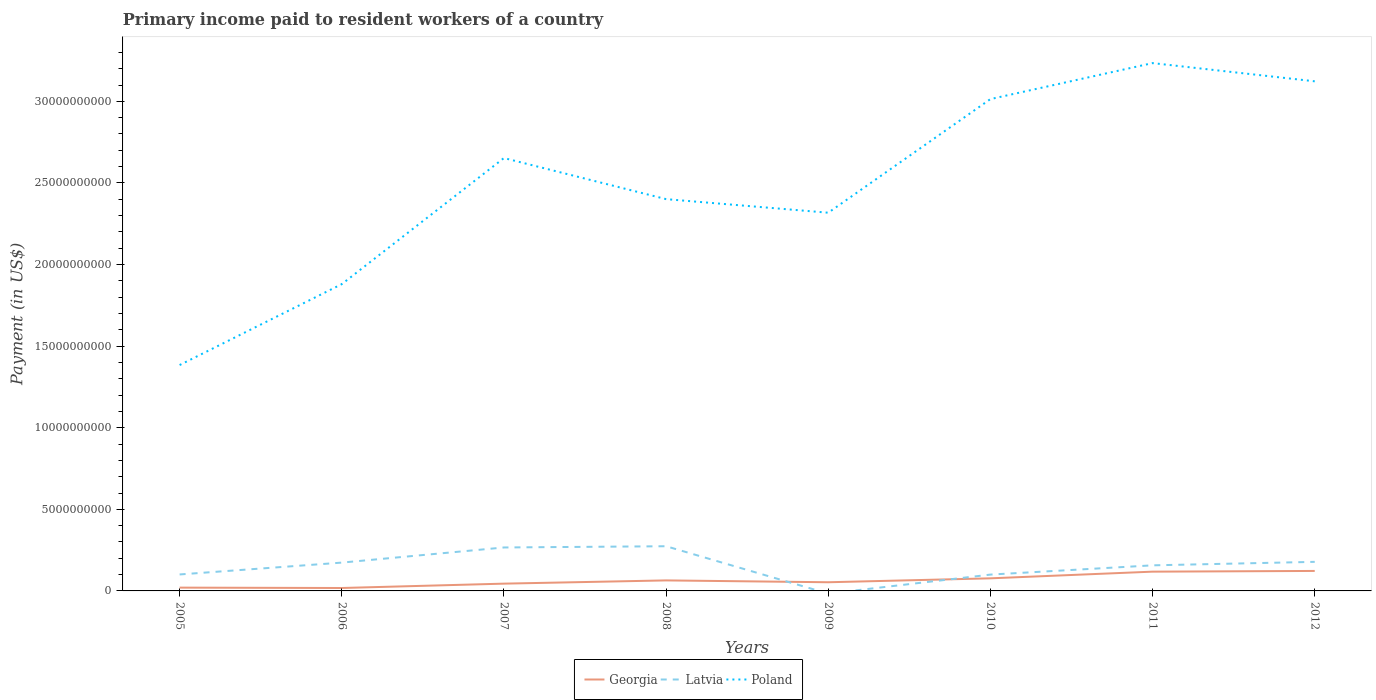Does the line corresponding to Georgia intersect with the line corresponding to Poland?
Your answer should be compact. No. Across all years, what is the maximum amount paid to workers in Georgia?
Give a very brief answer. 1.79e+08. What is the total amount paid to workers in Poland in the graph?
Offer a terse response. -5.82e+09. What is the difference between the highest and the second highest amount paid to workers in Georgia?
Provide a short and direct response. 1.05e+09. What is the difference between the highest and the lowest amount paid to workers in Latvia?
Your response must be concise. 5. Is the amount paid to workers in Georgia strictly greater than the amount paid to workers in Latvia over the years?
Your response must be concise. No. How many years are there in the graph?
Your response must be concise. 8. What is the difference between two consecutive major ticks on the Y-axis?
Give a very brief answer. 5.00e+09. Does the graph contain grids?
Give a very brief answer. No. How many legend labels are there?
Offer a very short reply. 3. How are the legend labels stacked?
Give a very brief answer. Horizontal. What is the title of the graph?
Give a very brief answer. Primary income paid to resident workers of a country. What is the label or title of the Y-axis?
Keep it short and to the point. Payment (in US$). What is the Payment (in US$) in Georgia in 2005?
Provide a short and direct response. 2.02e+08. What is the Payment (in US$) of Latvia in 2005?
Your response must be concise. 1.01e+09. What is the Payment (in US$) in Poland in 2005?
Give a very brief answer. 1.38e+1. What is the Payment (in US$) of Georgia in 2006?
Give a very brief answer. 1.79e+08. What is the Payment (in US$) of Latvia in 2006?
Offer a terse response. 1.74e+09. What is the Payment (in US$) of Poland in 2006?
Make the answer very short. 1.88e+1. What is the Payment (in US$) of Georgia in 2007?
Keep it short and to the point. 4.46e+08. What is the Payment (in US$) of Latvia in 2007?
Make the answer very short. 2.66e+09. What is the Payment (in US$) of Poland in 2007?
Give a very brief answer. 2.65e+1. What is the Payment (in US$) of Georgia in 2008?
Make the answer very short. 6.44e+08. What is the Payment (in US$) in Latvia in 2008?
Ensure brevity in your answer.  2.74e+09. What is the Payment (in US$) in Poland in 2008?
Your answer should be compact. 2.40e+1. What is the Payment (in US$) of Georgia in 2009?
Your answer should be compact. 5.31e+08. What is the Payment (in US$) in Poland in 2009?
Your response must be concise. 2.32e+1. What is the Payment (in US$) of Georgia in 2010?
Provide a succinct answer. 7.71e+08. What is the Payment (in US$) in Latvia in 2010?
Make the answer very short. 1.00e+09. What is the Payment (in US$) of Poland in 2010?
Provide a short and direct response. 3.01e+1. What is the Payment (in US$) in Georgia in 2011?
Provide a succinct answer. 1.18e+09. What is the Payment (in US$) of Latvia in 2011?
Your response must be concise. 1.57e+09. What is the Payment (in US$) of Poland in 2011?
Your response must be concise. 3.23e+1. What is the Payment (in US$) in Georgia in 2012?
Provide a succinct answer. 1.22e+09. What is the Payment (in US$) of Latvia in 2012?
Ensure brevity in your answer.  1.78e+09. What is the Payment (in US$) of Poland in 2012?
Make the answer very short. 3.12e+1. Across all years, what is the maximum Payment (in US$) in Georgia?
Offer a very short reply. 1.22e+09. Across all years, what is the maximum Payment (in US$) in Latvia?
Provide a short and direct response. 2.74e+09. Across all years, what is the maximum Payment (in US$) in Poland?
Your answer should be very brief. 3.23e+1. Across all years, what is the minimum Payment (in US$) of Georgia?
Your answer should be very brief. 1.79e+08. Across all years, what is the minimum Payment (in US$) in Poland?
Your answer should be compact. 1.38e+1. What is the total Payment (in US$) in Georgia in the graph?
Your answer should be compact. 5.18e+09. What is the total Payment (in US$) in Latvia in the graph?
Make the answer very short. 1.25e+1. What is the total Payment (in US$) in Poland in the graph?
Make the answer very short. 2.00e+11. What is the difference between the Payment (in US$) in Georgia in 2005 and that in 2006?
Your answer should be very brief. 2.26e+07. What is the difference between the Payment (in US$) in Latvia in 2005 and that in 2006?
Your answer should be compact. -7.26e+08. What is the difference between the Payment (in US$) of Poland in 2005 and that in 2006?
Your answer should be compact. -4.96e+09. What is the difference between the Payment (in US$) of Georgia in 2005 and that in 2007?
Offer a terse response. -2.44e+08. What is the difference between the Payment (in US$) in Latvia in 2005 and that in 2007?
Give a very brief answer. -1.65e+09. What is the difference between the Payment (in US$) of Poland in 2005 and that in 2007?
Offer a very short reply. -1.27e+1. What is the difference between the Payment (in US$) in Georgia in 2005 and that in 2008?
Offer a terse response. -4.42e+08. What is the difference between the Payment (in US$) of Latvia in 2005 and that in 2008?
Your response must be concise. -1.73e+09. What is the difference between the Payment (in US$) in Poland in 2005 and that in 2008?
Keep it short and to the point. -1.02e+1. What is the difference between the Payment (in US$) in Georgia in 2005 and that in 2009?
Offer a terse response. -3.29e+08. What is the difference between the Payment (in US$) of Poland in 2005 and that in 2009?
Offer a terse response. -9.34e+09. What is the difference between the Payment (in US$) of Georgia in 2005 and that in 2010?
Ensure brevity in your answer.  -5.70e+08. What is the difference between the Payment (in US$) of Latvia in 2005 and that in 2010?
Keep it short and to the point. 8.55e+06. What is the difference between the Payment (in US$) in Poland in 2005 and that in 2010?
Make the answer very short. -1.63e+1. What is the difference between the Payment (in US$) in Georgia in 2005 and that in 2011?
Give a very brief answer. -9.79e+08. What is the difference between the Payment (in US$) in Latvia in 2005 and that in 2011?
Ensure brevity in your answer.  -5.59e+08. What is the difference between the Payment (in US$) in Poland in 2005 and that in 2011?
Make the answer very short. -1.85e+1. What is the difference between the Payment (in US$) in Georgia in 2005 and that in 2012?
Keep it short and to the point. -1.02e+09. What is the difference between the Payment (in US$) of Latvia in 2005 and that in 2012?
Provide a succinct answer. -7.72e+08. What is the difference between the Payment (in US$) in Poland in 2005 and that in 2012?
Offer a very short reply. -1.74e+1. What is the difference between the Payment (in US$) of Georgia in 2006 and that in 2007?
Provide a short and direct response. -2.67e+08. What is the difference between the Payment (in US$) of Latvia in 2006 and that in 2007?
Provide a short and direct response. -9.28e+08. What is the difference between the Payment (in US$) of Poland in 2006 and that in 2007?
Keep it short and to the point. -7.73e+09. What is the difference between the Payment (in US$) of Georgia in 2006 and that in 2008?
Give a very brief answer. -4.65e+08. What is the difference between the Payment (in US$) in Latvia in 2006 and that in 2008?
Make the answer very short. -1.00e+09. What is the difference between the Payment (in US$) of Poland in 2006 and that in 2008?
Your answer should be very brief. -5.21e+09. What is the difference between the Payment (in US$) in Georgia in 2006 and that in 2009?
Ensure brevity in your answer.  -3.52e+08. What is the difference between the Payment (in US$) of Poland in 2006 and that in 2009?
Your answer should be very brief. -4.38e+09. What is the difference between the Payment (in US$) in Georgia in 2006 and that in 2010?
Offer a very short reply. -5.92e+08. What is the difference between the Payment (in US$) of Latvia in 2006 and that in 2010?
Your response must be concise. 7.35e+08. What is the difference between the Payment (in US$) in Poland in 2006 and that in 2010?
Your answer should be compact. -1.13e+1. What is the difference between the Payment (in US$) in Georgia in 2006 and that in 2011?
Your answer should be very brief. -1.00e+09. What is the difference between the Payment (in US$) in Latvia in 2006 and that in 2011?
Keep it short and to the point. 1.67e+08. What is the difference between the Payment (in US$) in Poland in 2006 and that in 2011?
Your answer should be very brief. -1.35e+1. What is the difference between the Payment (in US$) in Georgia in 2006 and that in 2012?
Offer a terse response. -1.05e+09. What is the difference between the Payment (in US$) of Latvia in 2006 and that in 2012?
Provide a short and direct response. -4.64e+07. What is the difference between the Payment (in US$) of Poland in 2006 and that in 2012?
Your response must be concise. -1.24e+1. What is the difference between the Payment (in US$) in Georgia in 2007 and that in 2008?
Ensure brevity in your answer.  -1.99e+08. What is the difference between the Payment (in US$) in Latvia in 2007 and that in 2008?
Offer a very short reply. -7.55e+07. What is the difference between the Payment (in US$) in Poland in 2007 and that in 2008?
Ensure brevity in your answer.  2.52e+09. What is the difference between the Payment (in US$) in Georgia in 2007 and that in 2009?
Keep it short and to the point. -8.53e+07. What is the difference between the Payment (in US$) of Poland in 2007 and that in 2009?
Your answer should be very brief. 3.35e+09. What is the difference between the Payment (in US$) of Georgia in 2007 and that in 2010?
Keep it short and to the point. -3.26e+08. What is the difference between the Payment (in US$) in Latvia in 2007 and that in 2010?
Your answer should be compact. 1.66e+09. What is the difference between the Payment (in US$) in Poland in 2007 and that in 2010?
Offer a very short reply. -3.61e+09. What is the difference between the Payment (in US$) of Georgia in 2007 and that in 2011?
Provide a succinct answer. -7.35e+08. What is the difference between the Payment (in US$) of Latvia in 2007 and that in 2011?
Provide a succinct answer. 1.09e+09. What is the difference between the Payment (in US$) in Poland in 2007 and that in 2011?
Provide a short and direct response. -5.82e+09. What is the difference between the Payment (in US$) of Georgia in 2007 and that in 2012?
Offer a very short reply. -7.79e+08. What is the difference between the Payment (in US$) of Latvia in 2007 and that in 2012?
Your response must be concise. 8.81e+08. What is the difference between the Payment (in US$) of Poland in 2007 and that in 2012?
Your response must be concise. -4.70e+09. What is the difference between the Payment (in US$) of Georgia in 2008 and that in 2009?
Provide a short and direct response. 1.13e+08. What is the difference between the Payment (in US$) in Poland in 2008 and that in 2009?
Offer a terse response. 8.32e+08. What is the difference between the Payment (in US$) of Georgia in 2008 and that in 2010?
Your answer should be very brief. -1.27e+08. What is the difference between the Payment (in US$) in Latvia in 2008 and that in 2010?
Your answer should be compact. 1.74e+09. What is the difference between the Payment (in US$) in Poland in 2008 and that in 2010?
Make the answer very short. -6.13e+09. What is the difference between the Payment (in US$) of Georgia in 2008 and that in 2011?
Provide a short and direct response. -5.37e+08. What is the difference between the Payment (in US$) of Latvia in 2008 and that in 2011?
Keep it short and to the point. 1.17e+09. What is the difference between the Payment (in US$) of Poland in 2008 and that in 2011?
Your response must be concise. -8.34e+09. What is the difference between the Payment (in US$) of Georgia in 2008 and that in 2012?
Provide a short and direct response. -5.80e+08. What is the difference between the Payment (in US$) in Latvia in 2008 and that in 2012?
Keep it short and to the point. 9.57e+08. What is the difference between the Payment (in US$) in Poland in 2008 and that in 2012?
Make the answer very short. -7.22e+09. What is the difference between the Payment (in US$) of Georgia in 2009 and that in 2010?
Provide a short and direct response. -2.40e+08. What is the difference between the Payment (in US$) in Poland in 2009 and that in 2010?
Your answer should be very brief. -6.96e+09. What is the difference between the Payment (in US$) of Georgia in 2009 and that in 2011?
Make the answer very short. -6.50e+08. What is the difference between the Payment (in US$) of Poland in 2009 and that in 2011?
Make the answer very short. -9.17e+09. What is the difference between the Payment (in US$) in Georgia in 2009 and that in 2012?
Your response must be concise. -6.93e+08. What is the difference between the Payment (in US$) in Poland in 2009 and that in 2012?
Give a very brief answer. -8.05e+09. What is the difference between the Payment (in US$) in Georgia in 2010 and that in 2011?
Your response must be concise. -4.10e+08. What is the difference between the Payment (in US$) of Latvia in 2010 and that in 2011?
Ensure brevity in your answer.  -5.67e+08. What is the difference between the Payment (in US$) in Poland in 2010 and that in 2011?
Keep it short and to the point. -2.20e+09. What is the difference between the Payment (in US$) of Georgia in 2010 and that in 2012?
Give a very brief answer. -4.53e+08. What is the difference between the Payment (in US$) in Latvia in 2010 and that in 2012?
Ensure brevity in your answer.  -7.81e+08. What is the difference between the Payment (in US$) in Poland in 2010 and that in 2012?
Your response must be concise. -1.09e+09. What is the difference between the Payment (in US$) in Georgia in 2011 and that in 2012?
Your answer should be compact. -4.35e+07. What is the difference between the Payment (in US$) in Latvia in 2011 and that in 2012?
Keep it short and to the point. -2.14e+08. What is the difference between the Payment (in US$) in Poland in 2011 and that in 2012?
Keep it short and to the point. 1.12e+09. What is the difference between the Payment (in US$) of Georgia in 2005 and the Payment (in US$) of Latvia in 2006?
Offer a very short reply. -1.53e+09. What is the difference between the Payment (in US$) of Georgia in 2005 and the Payment (in US$) of Poland in 2006?
Your answer should be very brief. -1.86e+1. What is the difference between the Payment (in US$) in Latvia in 2005 and the Payment (in US$) in Poland in 2006?
Give a very brief answer. -1.78e+1. What is the difference between the Payment (in US$) of Georgia in 2005 and the Payment (in US$) of Latvia in 2007?
Make the answer very short. -2.46e+09. What is the difference between the Payment (in US$) in Georgia in 2005 and the Payment (in US$) in Poland in 2007?
Keep it short and to the point. -2.63e+1. What is the difference between the Payment (in US$) in Latvia in 2005 and the Payment (in US$) in Poland in 2007?
Make the answer very short. -2.55e+1. What is the difference between the Payment (in US$) of Georgia in 2005 and the Payment (in US$) of Latvia in 2008?
Offer a terse response. -2.54e+09. What is the difference between the Payment (in US$) of Georgia in 2005 and the Payment (in US$) of Poland in 2008?
Ensure brevity in your answer.  -2.38e+1. What is the difference between the Payment (in US$) of Latvia in 2005 and the Payment (in US$) of Poland in 2008?
Your answer should be compact. -2.30e+1. What is the difference between the Payment (in US$) in Georgia in 2005 and the Payment (in US$) in Poland in 2009?
Offer a terse response. -2.30e+1. What is the difference between the Payment (in US$) in Latvia in 2005 and the Payment (in US$) in Poland in 2009?
Keep it short and to the point. -2.22e+1. What is the difference between the Payment (in US$) in Georgia in 2005 and the Payment (in US$) in Latvia in 2010?
Ensure brevity in your answer.  -7.99e+08. What is the difference between the Payment (in US$) of Georgia in 2005 and the Payment (in US$) of Poland in 2010?
Provide a succinct answer. -2.99e+1. What is the difference between the Payment (in US$) of Latvia in 2005 and the Payment (in US$) of Poland in 2010?
Provide a short and direct response. -2.91e+1. What is the difference between the Payment (in US$) in Georgia in 2005 and the Payment (in US$) in Latvia in 2011?
Your response must be concise. -1.37e+09. What is the difference between the Payment (in US$) in Georgia in 2005 and the Payment (in US$) in Poland in 2011?
Your answer should be compact. -3.21e+1. What is the difference between the Payment (in US$) in Latvia in 2005 and the Payment (in US$) in Poland in 2011?
Provide a succinct answer. -3.13e+1. What is the difference between the Payment (in US$) in Georgia in 2005 and the Payment (in US$) in Latvia in 2012?
Your answer should be compact. -1.58e+09. What is the difference between the Payment (in US$) in Georgia in 2005 and the Payment (in US$) in Poland in 2012?
Keep it short and to the point. -3.10e+1. What is the difference between the Payment (in US$) of Latvia in 2005 and the Payment (in US$) of Poland in 2012?
Offer a terse response. -3.02e+1. What is the difference between the Payment (in US$) of Georgia in 2006 and the Payment (in US$) of Latvia in 2007?
Provide a short and direct response. -2.48e+09. What is the difference between the Payment (in US$) in Georgia in 2006 and the Payment (in US$) in Poland in 2007?
Make the answer very short. -2.63e+1. What is the difference between the Payment (in US$) in Latvia in 2006 and the Payment (in US$) in Poland in 2007?
Offer a very short reply. -2.48e+1. What is the difference between the Payment (in US$) in Georgia in 2006 and the Payment (in US$) in Latvia in 2008?
Offer a very short reply. -2.56e+09. What is the difference between the Payment (in US$) of Georgia in 2006 and the Payment (in US$) of Poland in 2008?
Keep it short and to the point. -2.38e+1. What is the difference between the Payment (in US$) of Latvia in 2006 and the Payment (in US$) of Poland in 2008?
Give a very brief answer. -2.23e+1. What is the difference between the Payment (in US$) of Georgia in 2006 and the Payment (in US$) of Poland in 2009?
Your answer should be compact. -2.30e+1. What is the difference between the Payment (in US$) of Latvia in 2006 and the Payment (in US$) of Poland in 2009?
Offer a terse response. -2.14e+1. What is the difference between the Payment (in US$) in Georgia in 2006 and the Payment (in US$) in Latvia in 2010?
Keep it short and to the point. -8.21e+08. What is the difference between the Payment (in US$) of Georgia in 2006 and the Payment (in US$) of Poland in 2010?
Your answer should be compact. -3.00e+1. What is the difference between the Payment (in US$) of Latvia in 2006 and the Payment (in US$) of Poland in 2010?
Make the answer very short. -2.84e+1. What is the difference between the Payment (in US$) in Georgia in 2006 and the Payment (in US$) in Latvia in 2011?
Provide a short and direct response. -1.39e+09. What is the difference between the Payment (in US$) of Georgia in 2006 and the Payment (in US$) of Poland in 2011?
Provide a succinct answer. -3.22e+1. What is the difference between the Payment (in US$) of Latvia in 2006 and the Payment (in US$) of Poland in 2011?
Provide a succinct answer. -3.06e+1. What is the difference between the Payment (in US$) in Georgia in 2006 and the Payment (in US$) in Latvia in 2012?
Give a very brief answer. -1.60e+09. What is the difference between the Payment (in US$) in Georgia in 2006 and the Payment (in US$) in Poland in 2012?
Offer a terse response. -3.10e+1. What is the difference between the Payment (in US$) in Latvia in 2006 and the Payment (in US$) in Poland in 2012?
Make the answer very short. -2.95e+1. What is the difference between the Payment (in US$) in Georgia in 2007 and the Payment (in US$) in Latvia in 2008?
Offer a very short reply. -2.29e+09. What is the difference between the Payment (in US$) in Georgia in 2007 and the Payment (in US$) in Poland in 2008?
Your response must be concise. -2.36e+1. What is the difference between the Payment (in US$) of Latvia in 2007 and the Payment (in US$) of Poland in 2008?
Make the answer very short. -2.13e+1. What is the difference between the Payment (in US$) of Georgia in 2007 and the Payment (in US$) of Poland in 2009?
Provide a short and direct response. -2.27e+1. What is the difference between the Payment (in US$) of Latvia in 2007 and the Payment (in US$) of Poland in 2009?
Ensure brevity in your answer.  -2.05e+1. What is the difference between the Payment (in US$) in Georgia in 2007 and the Payment (in US$) in Latvia in 2010?
Offer a very short reply. -5.55e+08. What is the difference between the Payment (in US$) of Georgia in 2007 and the Payment (in US$) of Poland in 2010?
Make the answer very short. -2.97e+1. What is the difference between the Payment (in US$) in Latvia in 2007 and the Payment (in US$) in Poland in 2010?
Ensure brevity in your answer.  -2.75e+1. What is the difference between the Payment (in US$) in Georgia in 2007 and the Payment (in US$) in Latvia in 2011?
Your response must be concise. -1.12e+09. What is the difference between the Payment (in US$) of Georgia in 2007 and the Payment (in US$) of Poland in 2011?
Your answer should be compact. -3.19e+1. What is the difference between the Payment (in US$) of Latvia in 2007 and the Payment (in US$) of Poland in 2011?
Ensure brevity in your answer.  -2.97e+1. What is the difference between the Payment (in US$) in Georgia in 2007 and the Payment (in US$) in Latvia in 2012?
Your answer should be very brief. -1.34e+09. What is the difference between the Payment (in US$) in Georgia in 2007 and the Payment (in US$) in Poland in 2012?
Provide a succinct answer. -3.08e+1. What is the difference between the Payment (in US$) of Latvia in 2007 and the Payment (in US$) of Poland in 2012?
Provide a short and direct response. -2.86e+1. What is the difference between the Payment (in US$) of Georgia in 2008 and the Payment (in US$) of Poland in 2009?
Your answer should be very brief. -2.25e+1. What is the difference between the Payment (in US$) of Latvia in 2008 and the Payment (in US$) of Poland in 2009?
Keep it short and to the point. -2.04e+1. What is the difference between the Payment (in US$) of Georgia in 2008 and the Payment (in US$) of Latvia in 2010?
Your answer should be very brief. -3.56e+08. What is the difference between the Payment (in US$) in Georgia in 2008 and the Payment (in US$) in Poland in 2010?
Offer a terse response. -2.95e+1. What is the difference between the Payment (in US$) of Latvia in 2008 and the Payment (in US$) of Poland in 2010?
Give a very brief answer. -2.74e+1. What is the difference between the Payment (in US$) of Georgia in 2008 and the Payment (in US$) of Latvia in 2011?
Provide a short and direct response. -9.24e+08. What is the difference between the Payment (in US$) in Georgia in 2008 and the Payment (in US$) in Poland in 2011?
Ensure brevity in your answer.  -3.17e+1. What is the difference between the Payment (in US$) of Latvia in 2008 and the Payment (in US$) of Poland in 2011?
Provide a succinct answer. -2.96e+1. What is the difference between the Payment (in US$) in Georgia in 2008 and the Payment (in US$) in Latvia in 2012?
Keep it short and to the point. -1.14e+09. What is the difference between the Payment (in US$) in Georgia in 2008 and the Payment (in US$) in Poland in 2012?
Offer a very short reply. -3.06e+1. What is the difference between the Payment (in US$) in Latvia in 2008 and the Payment (in US$) in Poland in 2012?
Keep it short and to the point. -2.85e+1. What is the difference between the Payment (in US$) of Georgia in 2009 and the Payment (in US$) of Latvia in 2010?
Make the answer very short. -4.69e+08. What is the difference between the Payment (in US$) of Georgia in 2009 and the Payment (in US$) of Poland in 2010?
Provide a short and direct response. -2.96e+1. What is the difference between the Payment (in US$) in Georgia in 2009 and the Payment (in US$) in Latvia in 2011?
Offer a very short reply. -1.04e+09. What is the difference between the Payment (in US$) in Georgia in 2009 and the Payment (in US$) in Poland in 2011?
Ensure brevity in your answer.  -3.18e+1. What is the difference between the Payment (in US$) of Georgia in 2009 and the Payment (in US$) of Latvia in 2012?
Ensure brevity in your answer.  -1.25e+09. What is the difference between the Payment (in US$) in Georgia in 2009 and the Payment (in US$) in Poland in 2012?
Make the answer very short. -3.07e+1. What is the difference between the Payment (in US$) of Georgia in 2010 and the Payment (in US$) of Latvia in 2011?
Your response must be concise. -7.97e+08. What is the difference between the Payment (in US$) in Georgia in 2010 and the Payment (in US$) in Poland in 2011?
Make the answer very short. -3.16e+1. What is the difference between the Payment (in US$) of Latvia in 2010 and the Payment (in US$) of Poland in 2011?
Offer a terse response. -3.13e+1. What is the difference between the Payment (in US$) of Georgia in 2010 and the Payment (in US$) of Latvia in 2012?
Offer a terse response. -1.01e+09. What is the difference between the Payment (in US$) of Georgia in 2010 and the Payment (in US$) of Poland in 2012?
Your answer should be compact. -3.05e+1. What is the difference between the Payment (in US$) in Latvia in 2010 and the Payment (in US$) in Poland in 2012?
Give a very brief answer. -3.02e+1. What is the difference between the Payment (in US$) of Georgia in 2011 and the Payment (in US$) of Latvia in 2012?
Offer a very short reply. -6.01e+08. What is the difference between the Payment (in US$) in Georgia in 2011 and the Payment (in US$) in Poland in 2012?
Provide a short and direct response. -3.00e+1. What is the difference between the Payment (in US$) in Latvia in 2011 and the Payment (in US$) in Poland in 2012?
Provide a succinct answer. -2.97e+1. What is the average Payment (in US$) in Georgia per year?
Your answer should be very brief. 6.47e+08. What is the average Payment (in US$) of Latvia per year?
Offer a very short reply. 1.56e+09. What is the average Payment (in US$) in Poland per year?
Give a very brief answer. 2.50e+1. In the year 2005, what is the difference between the Payment (in US$) of Georgia and Payment (in US$) of Latvia?
Make the answer very short. -8.07e+08. In the year 2005, what is the difference between the Payment (in US$) of Georgia and Payment (in US$) of Poland?
Offer a very short reply. -1.36e+1. In the year 2005, what is the difference between the Payment (in US$) of Latvia and Payment (in US$) of Poland?
Your answer should be very brief. -1.28e+1. In the year 2006, what is the difference between the Payment (in US$) in Georgia and Payment (in US$) in Latvia?
Ensure brevity in your answer.  -1.56e+09. In the year 2006, what is the difference between the Payment (in US$) in Georgia and Payment (in US$) in Poland?
Your response must be concise. -1.86e+1. In the year 2006, what is the difference between the Payment (in US$) in Latvia and Payment (in US$) in Poland?
Keep it short and to the point. -1.71e+1. In the year 2007, what is the difference between the Payment (in US$) of Georgia and Payment (in US$) of Latvia?
Offer a very short reply. -2.22e+09. In the year 2007, what is the difference between the Payment (in US$) in Georgia and Payment (in US$) in Poland?
Give a very brief answer. -2.61e+1. In the year 2007, what is the difference between the Payment (in US$) of Latvia and Payment (in US$) of Poland?
Give a very brief answer. -2.39e+1. In the year 2008, what is the difference between the Payment (in US$) of Georgia and Payment (in US$) of Latvia?
Offer a terse response. -2.09e+09. In the year 2008, what is the difference between the Payment (in US$) in Georgia and Payment (in US$) in Poland?
Provide a succinct answer. -2.34e+1. In the year 2008, what is the difference between the Payment (in US$) in Latvia and Payment (in US$) in Poland?
Your answer should be very brief. -2.13e+1. In the year 2009, what is the difference between the Payment (in US$) of Georgia and Payment (in US$) of Poland?
Provide a succinct answer. -2.26e+1. In the year 2010, what is the difference between the Payment (in US$) in Georgia and Payment (in US$) in Latvia?
Make the answer very short. -2.29e+08. In the year 2010, what is the difference between the Payment (in US$) of Georgia and Payment (in US$) of Poland?
Provide a succinct answer. -2.94e+1. In the year 2010, what is the difference between the Payment (in US$) of Latvia and Payment (in US$) of Poland?
Provide a short and direct response. -2.91e+1. In the year 2011, what is the difference between the Payment (in US$) in Georgia and Payment (in US$) in Latvia?
Provide a succinct answer. -3.87e+08. In the year 2011, what is the difference between the Payment (in US$) in Georgia and Payment (in US$) in Poland?
Your answer should be compact. -3.12e+1. In the year 2011, what is the difference between the Payment (in US$) of Latvia and Payment (in US$) of Poland?
Offer a terse response. -3.08e+1. In the year 2012, what is the difference between the Payment (in US$) in Georgia and Payment (in US$) in Latvia?
Give a very brief answer. -5.57e+08. In the year 2012, what is the difference between the Payment (in US$) in Georgia and Payment (in US$) in Poland?
Ensure brevity in your answer.  -3.00e+1. In the year 2012, what is the difference between the Payment (in US$) in Latvia and Payment (in US$) in Poland?
Provide a short and direct response. -2.94e+1. What is the ratio of the Payment (in US$) in Georgia in 2005 to that in 2006?
Your response must be concise. 1.13. What is the ratio of the Payment (in US$) in Latvia in 2005 to that in 2006?
Keep it short and to the point. 0.58. What is the ratio of the Payment (in US$) in Poland in 2005 to that in 2006?
Make the answer very short. 0.74. What is the ratio of the Payment (in US$) of Georgia in 2005 to that in 2007?
Your response must be concise. 0.45. What is the ratio of the Payment (in US$) in Latvia in 2005 to that in 2007?
Provide a short and direct response. 0.38. What is the ratio of the Payment (in US$) in Poland in 2005 to that in 2007?
Provide a short and direct response. 0.52. What is the ratio of the Payment (in US$) of Georgia in 2005 to that in 2008?
Give a very brief answer. 0.31. What is the ratio of the Payment (in US$) in Latvia in 2005 to that in 2008?
Your answer should be very brief. 0.37. What is the ratio of the Payment (in US$) in Poland in 2005 to that in 2008?
Provide a succinct answer. 0.58. What is the ratio of the Payment (in US$) in Georgia in 2005 to that in 2009?
Your answer should be very brief. 0.38. What is the ratio of the Payment (in US$) in Poland in 2005 to that in 2009?
Provide a succinct answer. 0.6. What is the ratio of the Payment (in US$) in Georgia in 2005 to that in 2010?
Make the answer very short. 0.26. What is the ratio of the Payment (in US$) of Latvia in 2005 to that in 2010?
Your answer should be very brief. 1.01. What is the ratio of the Payment (in US$) in Poland in 2005 to that in 2010?
Your answer should be compact. 0.46. What is the ratio of the Payment (in US$) of Georgia in 2005 to that in 2011?
Ensure brevity in your answer.  0.17. What is the ratio of the Payment (in US$) of Latvia in 2005 to that in 2011?
Your answer should be very brief. 0.64. What is the ratio of the Payment (in US$) of Poland in 2005 to that in 2011?
Offer a very short reply. 0.43. What is the ratio of the Payment (in US$) in Georgia in 2005 to that in 2012?
Ensure brevity in your answer.  0.16. What is the ratio of the Payment (in US$) in Latvia in 2005 to that in 2012?
Ensure brevity in your answer.  0.57. What is the ratio of the Payment (in US$) of Poland in 2005 to that in 2012?
Provide a short and direct response. 0.44. What is the ratio of the Payment (in US$) in Georgia in 2006 to that in 2007?
Make the answer very short. 0.4. What is the ratio of the Payment (in US$) of Latvia in 2006 to that in 2007?
Keep it short and to the point. 0.65. What is the ratio of the Payment (in US$) in Poland in 2006 to that in 2007?
Provide a short and direct response. 0.71. What is the ratio of the Payment (in US$) in Georgia in 2006 to that in 2008?
Offer a terse response. 0.28. What is the ratio of the Payment (in US$) of Latvia in 2006 to that in 2008?
Provide a short and direct response. 0.63. What is the ratio of the Payment (in US$) of Poland in 2006 to that in 2008?
Your answer should be very brief. 0.78. What is the ratio of the Payment (in US$) of Georgia in 2006 to that in 2009?
Your response must be concise. 0.34. What is the ratio of the Payment (in US$) in Poland in 2006 to that in 2009?
Provide a short and direct response. 0.81. What is the ratio of the Payment (in US$) in Georgia in 2006 to that in 2010?
Offer a terse response. 0.23. What is the ratio of the Payment (in US$) in Latvia in 2006 to that in 2010?
Offer a terse response. 1.73. What is the ratio of the Payment (in US$) in Poland in 2006 to that in 2010?
Provide a succinct answer. 0.62. What is the ratio of the Payment (in US$) of Georgia in 2006 to that in 2011?
Make the answer very short. 0.15. What is the ratio of the Payment (in US$) in Latvia in 2006 to that in 2011?
Your answer should be very brief. 1.11. What is the ratio of the Payment (in US$) in Poland in 2006 to that in 2011?
Provide a succinct answer. 0.58. What is the ratio of the Payment (in US$) in Georgia in 2006 to that in 2012?
Ensure brevity in your answer.  0.15. What is the ratio of the Payment (in US$) of Latvia in 2006 to that in 2012?
Keep it short and to the point. 0.97. What is the ratio of the Payment (in US$) in Poland in 2006 to that in 2012?
Your answer should be compact. 0.6. What is the ratio of the Payment (in US$) of Georgia in 2007 to that in 2008?
Your answer should be compact. 0.69. What is the ratio of the Payment (in US$) of Latvia in 2007 to that in 2008?
Offer a terse response. 0.97. What is the ratio of the Payment (in US$) of Poland in 2007 to that in 2008?
Provide a short and direct response. 1.1. What is the ratio of the Payment (in US$) in Georgia in 2007 to that in 2009?
Your answer should be compact. 0.84. What is the ratio of the Payment (in US$) in Poland in 2007 to that in 2009?
Offer a terse response. 1.14. What is the ratio of the Payment (in US$) in Georgia in 2007 to that in 2010?
Your answer should be very brief. 0.58. What is the ratio of the Payment (in US$) in Latvia in 2007 to that in 2010?
Your answer should be compact. 2.66. What is the ratio of the Payment (in US$) in Poland in 2007 to that in 2010?
Ensure brevity in your answer.  0.88. What is the ratio of the Payment (in US$) of Georgia in 2007 to that in 2011?
Provide a succinct answer. 0.38. What is the ratio of the Payment (in US$) in Latvia in 2007 to that in 2011?
Keep it short and to the point. 1.7. What is the ratio of the Payment (in US$) in Poland in 2007 to that in 2011?
Your answer should be very brief. 0.82. What is the ratio of the Payment (in US$) in Georgia in 2007 to that in 2012?
Provide a succinct answer. 0.36. What is the ratio of the Payment (in US$) of Latvia in 2007 to that in 2012?
Give a very brief answer. 1.49. What is the ratio of the Payment (in US$) in Poland in 2007 to that in 2012?
Give a very brief answer. 0.85. What is the ratio of the Payment (in US$) of Georgia in 2008 to that in 2009?
Provide a succinct answer. 1.21. What is the ratio of the Payment (in US$) in Poland in 2008 to that in 2009?
Provide a succinct answer. 1.04. What is the ratio of the Payment (in US$) of Georgia in 2008 to that in 2010?
Your answer should be very brief. 0.84. What is the ratio of the Payment (in US$) in Latvia in 2008 to that in 2010?
Your answer should be compact. 2.74. What is the ratio of the Payment (in US$) of Poland in 2008 to that in 2010?
Provide a succinct answer. 0.8. What is the ratio of the Payment (in US$) of Georgia in 2008 to that in 2011?
Keep it short and to the point. 0.55. What is the ratio of the Payment (in US$) of Latvia in 2008 to that in 2011?
Provide a succinct answer. 1.75. What is the ratio of the Payment (in US$) in Poland in 2008 to that in 2011?
Your response must be concise. 0.74. What is the ratio of the Payment (in US$) of Georgia in 2008 to that in 2012?
Provide a short and direct response. 0.53. What is the ratio of the Payment (in US$) of Latvia in 2008 to that in 2012?
Provide a short and direct response. 1.54. What is the ratio of the Payment (in US$) of Poland in 2008 to that in 2012?
Provide a short and direct response. 0.77. What is the ratio of the Payment (in US$) in Georgia in 2009 to that in 2010?
Your answer should be very brief. 0.69. What is the ratio of the Payment (in US$) of Poland in 2009 to that in 2010?
Offer a terse response. 0.77. What is the ratio of the Payment (in US$) of Georgia in 2009 to that in 2011?
Offer a very short reply. 0.45. What is the ratio of the Payment (in US$) of Poland in 2009 to that in 2011?
Offer a terse response. 0.72. What is the ratio of the Payment (in US$) of Georgia in 2009 to that in 2012?
Your answer should be compact. 0.43. What is the ratio of the Payment (in US$) of Poland in 2009 to that in 2012?
Offer a terse response. 0.74. What is the ratio of the Payment (in US$) of Georgia in 2010 to that in 2011?
Keep it short and to the point. 0.65. What is the ratio of the Payment (in US$) of Latvia in 2010 to that in 2011?
Keep it short and to the point. 0.64. What is the ratio of the Payment (in US$) in Poland in 2010 to that in 2011?
Ensure brevity in your answer.  0.93. What is the ratio of the Payment (in US$) of Georgia in 2010 to that in 2012?
Provide a succinct answer. 0.63. What is the ratio of the Payment (in US$) in Latvia in 2010 to that in 2012?
Provide a succinct answer. 0.56. What is the ratio of the Payment (in US$) of Poland in 2010 to that in 2012?
Provide a succinct answer. 0.97. What is the ratio of the Payment (in US$) of Georgia in 2011 to that in 2012?
Keep it short and to the point. 0.96. What is the ratio of the Payment (in US$) in Latvia in 2011 to that in 2012?
Ensure brevity in your answer.  0.88. What is the ratio of the Payment (in US$) of Poland in 2011 to that in 2012?
Your answer should be very brief. 1.04. What is the difference between the highest and the second highest Payment (in US$) in Georgia?
Offer a terse response. 4.35e+07. What is the difference between the highest and the second highest Payment (in US$) of Latvia?
Provide a succinct answer. 7.55e+07. What is the difference between the highest and the second highest Payment (in US$) of Poland?
Keep it short and to the point. 1.12e+09. What is the difference between the highest and the lowest Payment (in US$) of Georgia?
Provide a short and direct response. 1.05e+09. What is the difference between the highest and the lowest Payment (in US$) of Latvia?
Make the answer very short. 2.74e+09. What is the difference between the highest and the lowest Payment (in US$) of Poland?
Your response must be concise. 1.85e+1. 